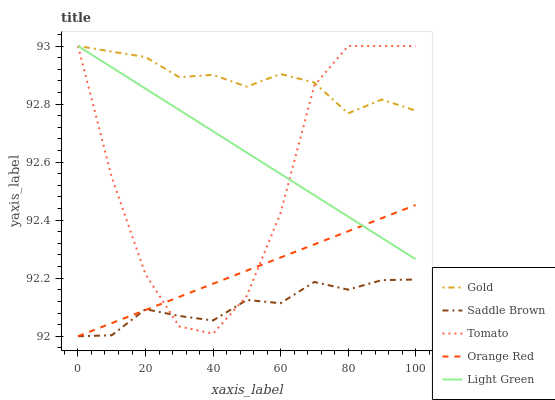Does Light Green have the minimum area under the curve?
Answer yes or no. No. Does Light Green have the maximum area under the curve?
Answer yes or no. No. Is Light Green the smoothest?
Answer yes or no. No. Is Light Green the roughest?
Answer yes or no. No. Does Light Green have the lowest value?
Answer yes or no. No. Does Saddle Brown have the highest value?
Answer yes or no. No. Is Saddle Brown less than Light Green?
Answer yes or no. Yes. Is Light Green greater than Saddle Brown?
Answer yes or no. Yes. Does Saddle Brown intersect Light Green?
Answer yes or no. No. 